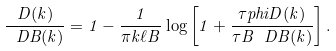Convert formula to latex. <formula><loc_0><loc_0><loc_500><loc_500>\frac { D ( k ) } { \ D B ( k ) } = 1 - \frac { 1 } { \pi k \ell B } \log \left [ 1 + \frac { \tau p h i D ( k ) } { \tau B \ D B ( k ) } \right ] .</formula> 